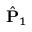<formula> <loc_0><loc_0><loc_500><loc_500>\hat { P } _ { 1 }</formula> 